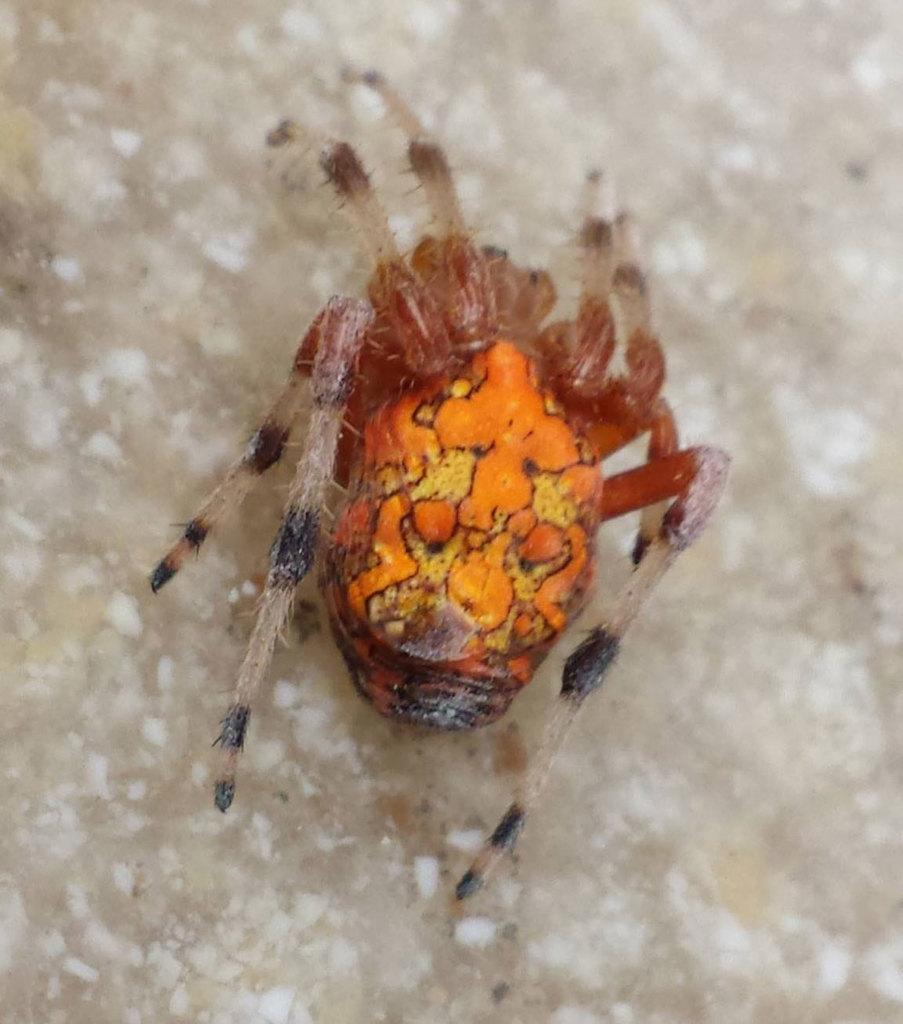Describe this image in one or two sentences. In this image, I can see an insect on an object. 